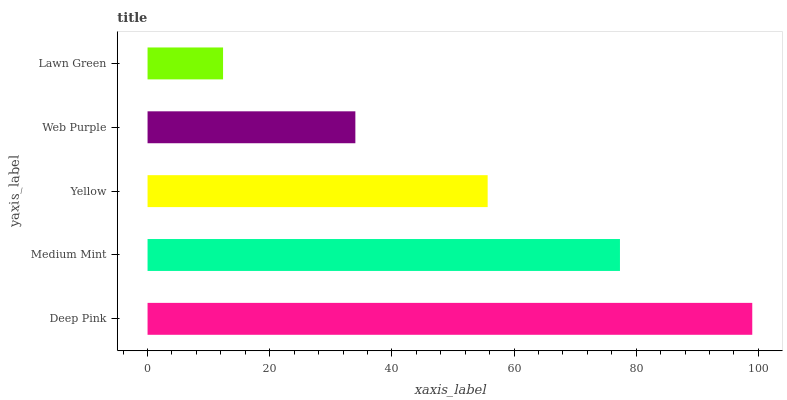Is Lawn Green the minimum?
Answer yes or no. Yes. Is Deep Pink the maximum?
Answer yes or no. Yes. Is Medium Mint the minimum?
Answer yes or no. No. Is Medium Mint the maximum?
Answer yes or no. No. Is Deep Pink greater than Medium Mint?
Answer yes or no. Yes. Is Medium Mint less than Deep Pink?
Answer yes or no. Yes. Is Medium Mint greater than Deep Pink?
Answer yes or no. No. Is Deep Pink less than Medium Mint?
Answer yes or no. No. Is Yellow the high median?
Answer yes or no. Yes. Is Yellow the low median?
Answer yes or no. Yes. Is Deep Pink the high median?
Answer yes or no. No. Is Deep Pink the low median?
Answer yes or no. No. 